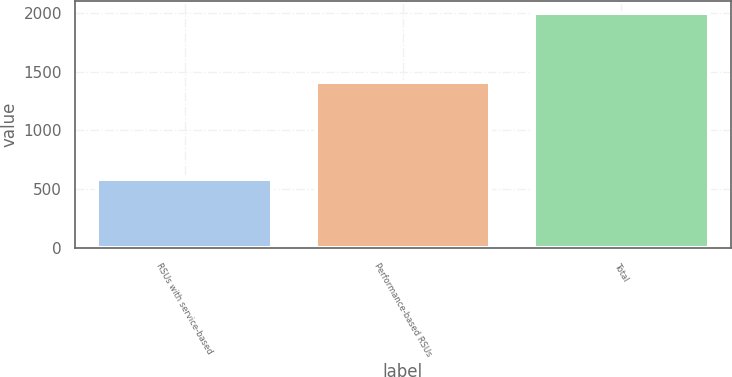Convert chart to OTSL. <chart><loc_0><loc_0><loc_500><loc_500><bar_chart><fcel>RSUs with service-based<fcel>Performance-based RSUs<fcel>Total<nl><fcel>588<fcel>1409<fcel>1997<nl></chart> 